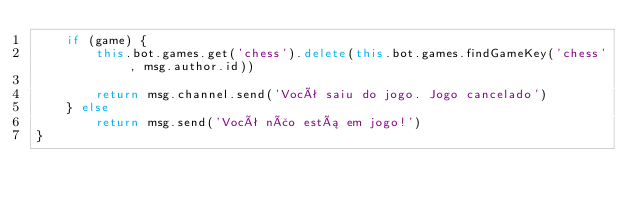Convert code to text. <code><loc_0><loc_0><loc_500><loc_500><_JavaScript_>    if (game) {
        this.bot.games.get('chess').delete(this.bot.games.findGameKey('chess', msg.author.id))

        return msg.channel.send('Você saiu do jogo. Jogo cancelado')
    } else
        return msg.send('Você não está em jogo!')
}
</code> 